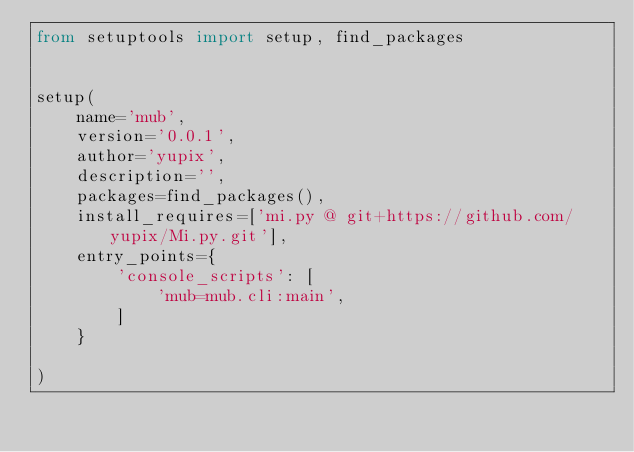<code> <loc_0><loc_0><loc_500><loc_500><_Python_>from setuptools import setup, find_packages


setup(
    name='mub',
    version='0.0.1',
    author='yupix',
    description='',
    packages=find_packages(),
    install_requires=['mi.py @ git+https://github.com/yupix/Mi.py.git'],
    entry_points={
        'console_scripts': [
            'mub=mub.cli:main',
        ]
    }

)
</code> 